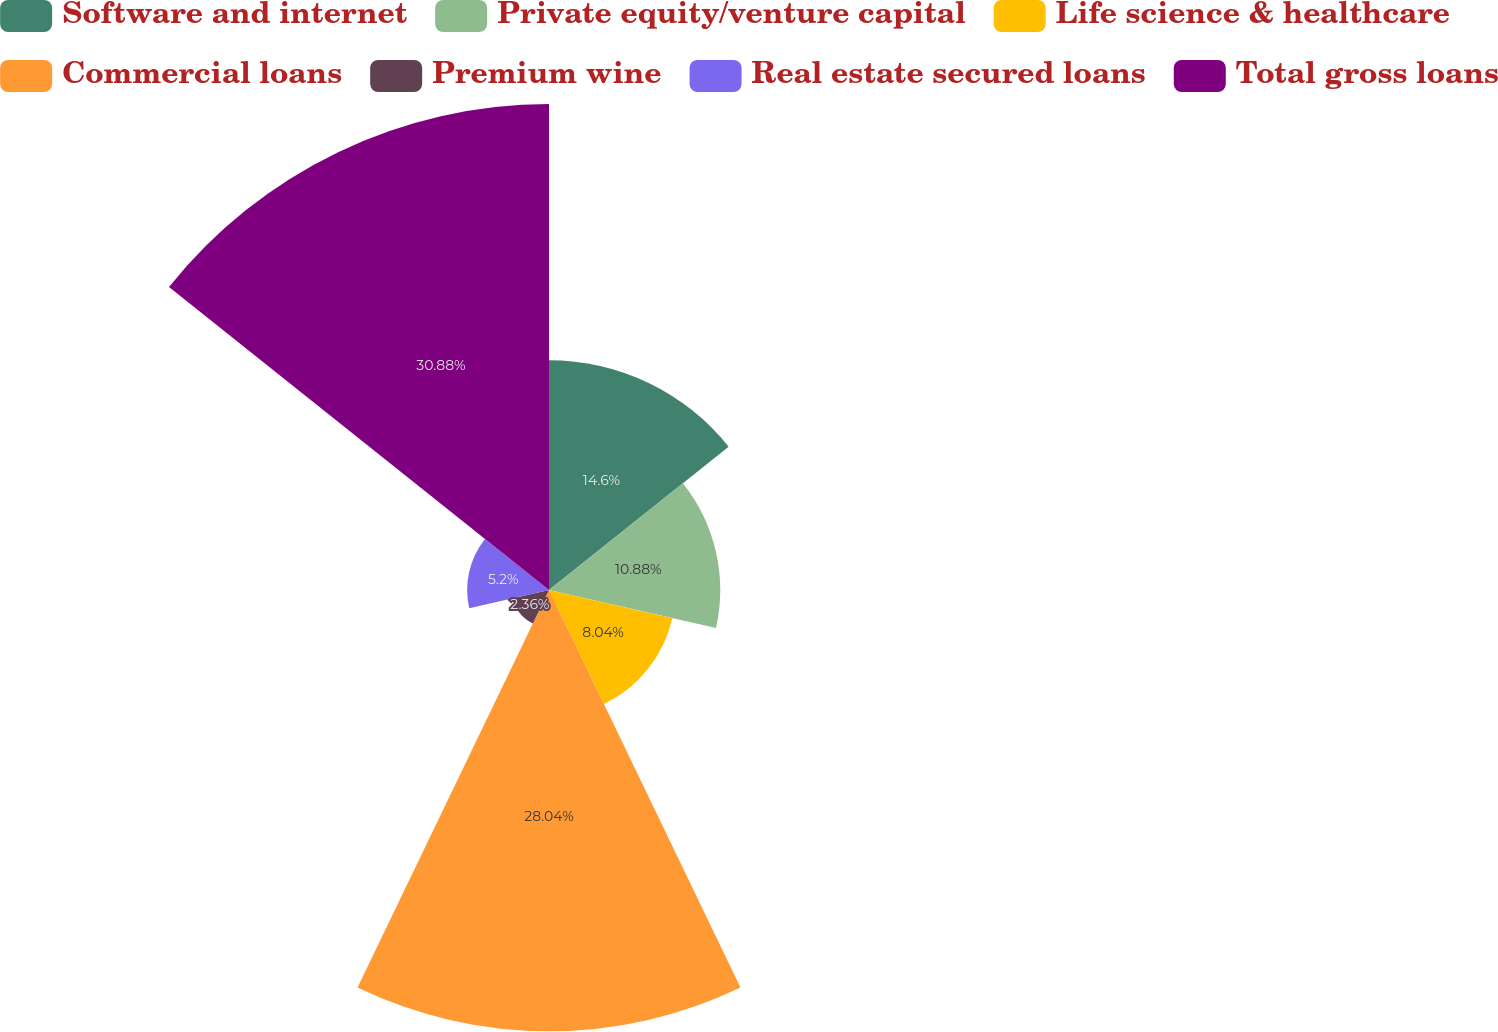Convert chart. <chart><loc_0><loc_0><loc_500><loc_500><pie_chart><fcel>Software and internet<fcel>Private equity/venture capital<fcel>Life science & healthcare<fcel>Commercial loans<fcel>Premium wine<fcel>Real estate secured loans<fcel>Total gross loans<nl><fcel>14.6%<fcel>10.88%<fcel>8.04%<fcel>28.04%<fcel>2.36%<fcel>5.2%<fcel>30.88%<nl></chart> 